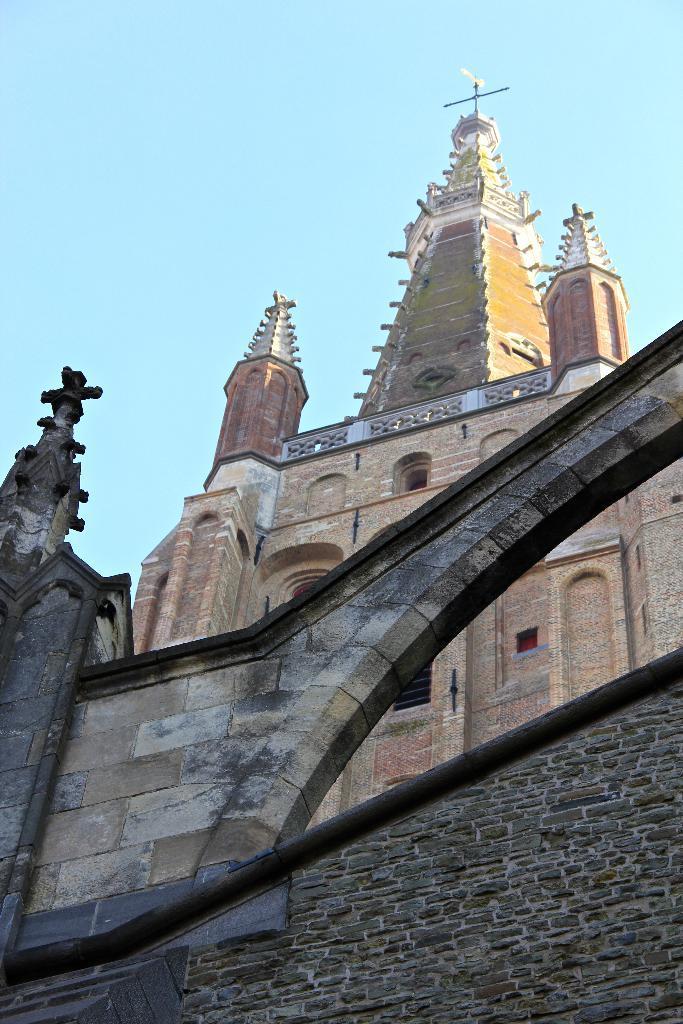Could you give a brief overview of what you see in this image? In the picture we can see church and a wall. We can also see cross symbols and sky. 